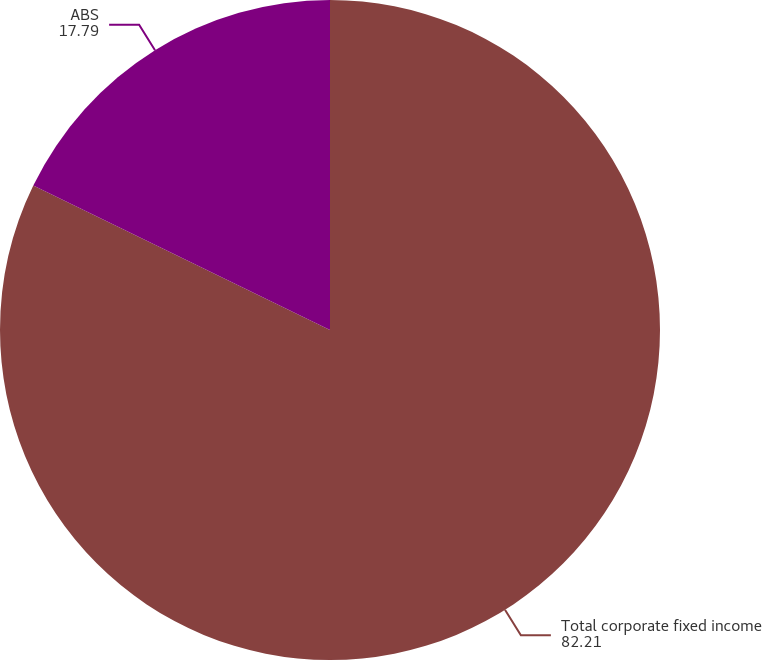<chart> <loc_0><loc_0><loc_500><loc_500><pie_chart><fcel>Total corporate fixed income<fcel>ABS<nl><fcel>82.21%<fcel>17.79%<nl></chart> 